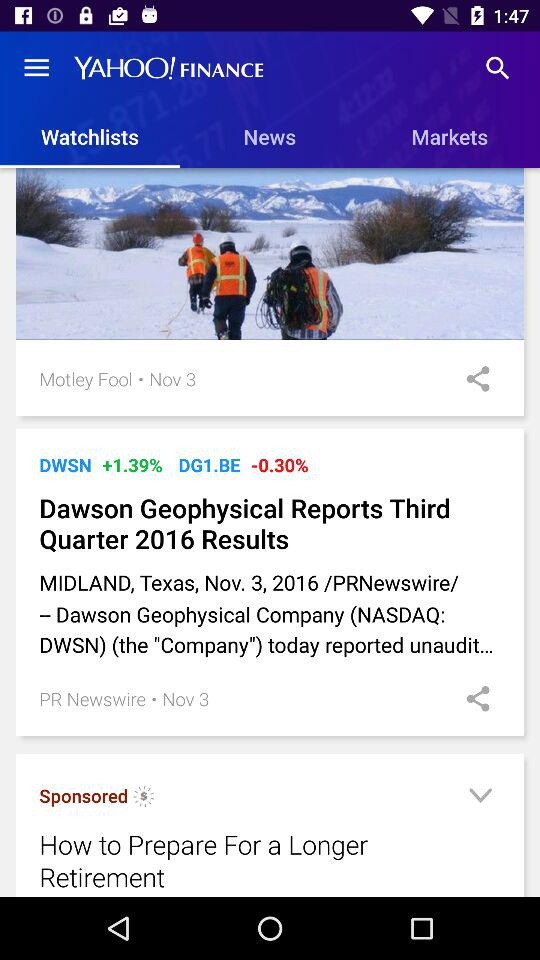Which is the selected tab? The selected tab is "Watchlists". 